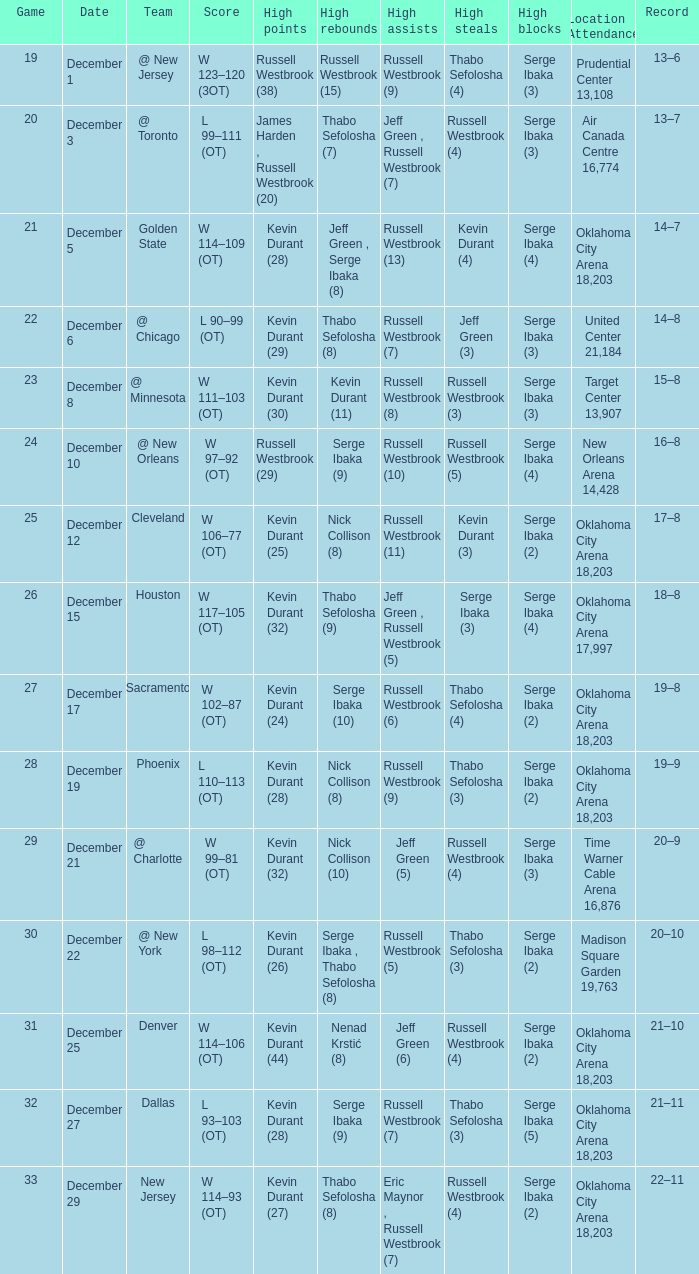What was the record on December 27? 21–11. 